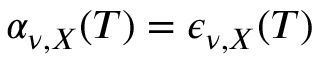<formula> <loc_0><loc_0><loc_500><loc_500>\alpha _ { \nu , X } ( T ) = \epsilon _ { \nu , X } ( T )</formula> 